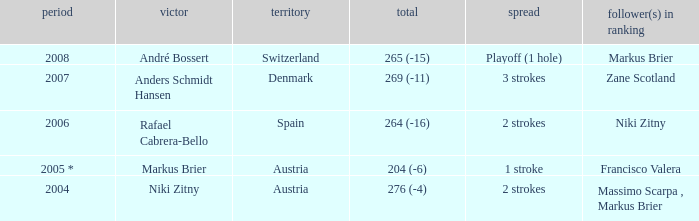Who was the runner-up when the margin was 1 stroke? Francisco Valera. 